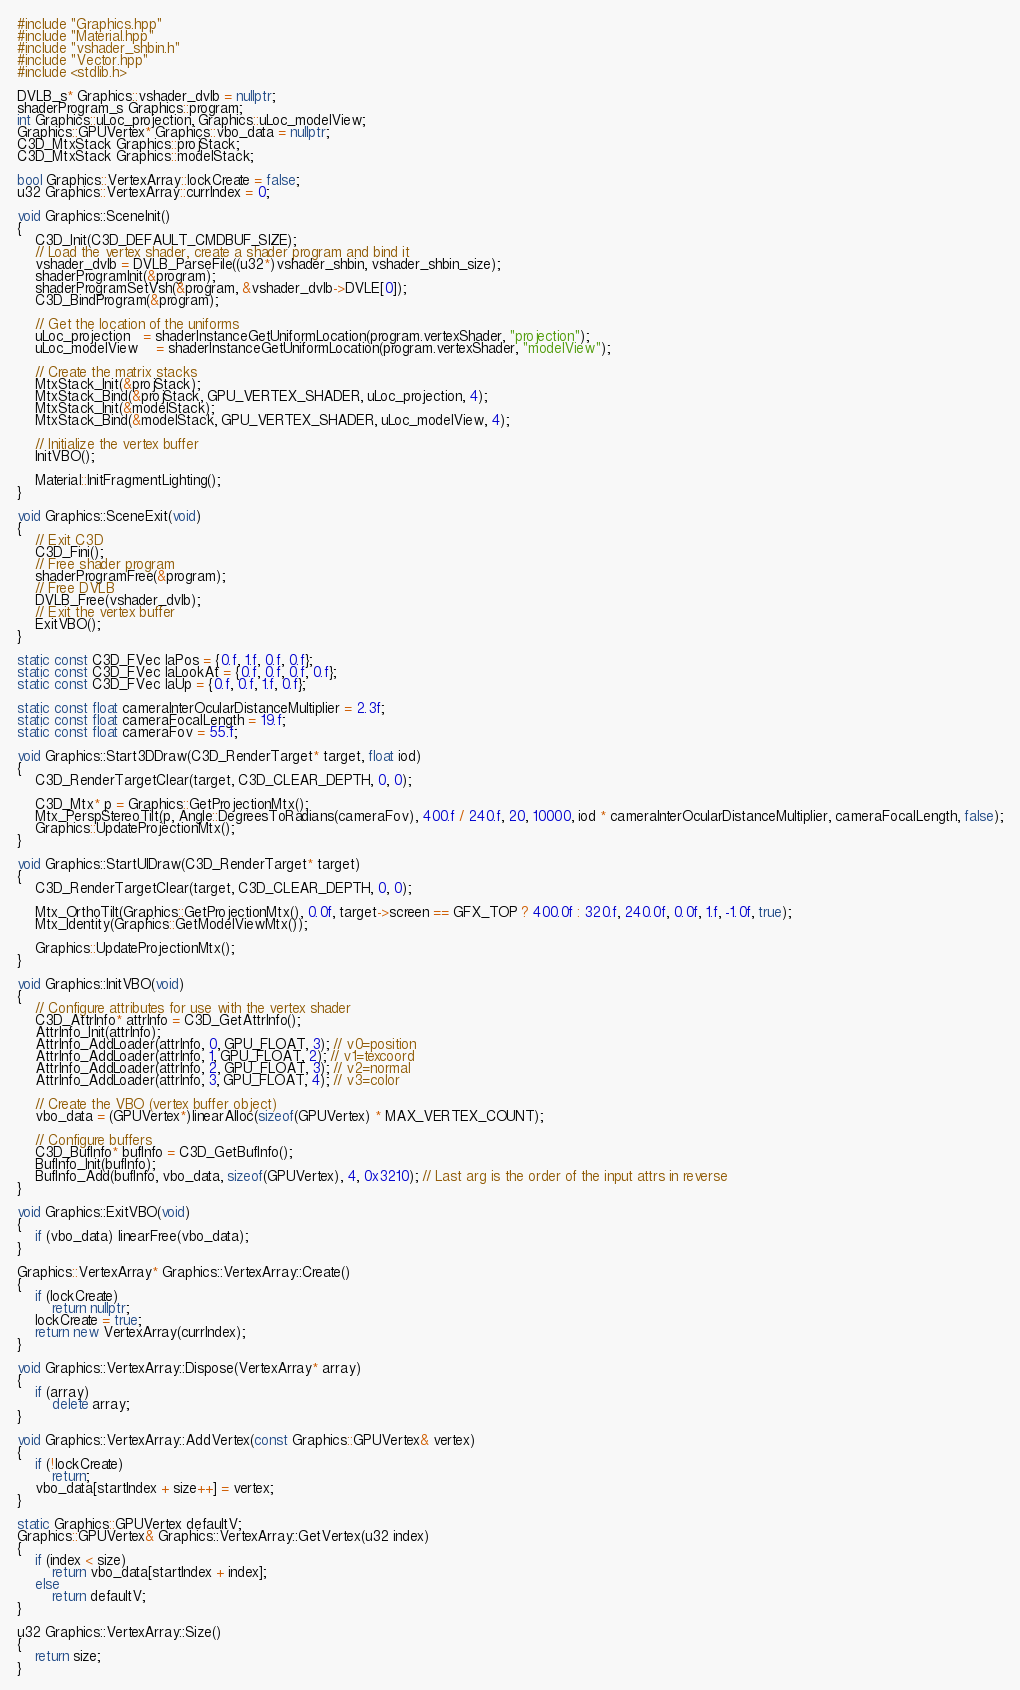<code> <loc_0><loc_0><loc_500><loc_500><_C++_>#include "Graphics.hpp"
#include "Material.hpp"
#include "vshader_shbin.h"
#include "Vector.hpp"
#include <stdlib.h>

DVLB_s* Graphics::vshader_dvlb = nullptr;
shaderProgram_s Graphics::program;
int Graphics::uLoc_projection, Graphics::uLoc_modelView;
Graphics::GPUVertex* Graphics::vbo_data = nullptr;
C3D_MtxStack Graphics::projStack;
C3D_MtxStack Graphics::modelStack;

bool Graphics::VertexArray::lockCreate = false;
u32 Graphics::VertexArray::currIndex = 0;

void Graphics::SceneInit()
{
	C3D_Init(C3D_DEFAULT_CMDBUF_SIZE);
    // Load the vertex shader, create a shader program and bind it
	vshader_dvlb = DVLB_ParseFile((u32*)vshader_shbin, vshader_shbin_size);
	shaderProgramInit(&program);
	shaderProgramSetVsh(&program, &vshader_dvlb->DVLE[0]);
	C3D_BindProgram(&program);

	// Get the location of the uniforms
	uLoc_projection   = shaderInstanceGetUniformLocation(program.vertexShader, "projection");
	uLoc_modelView    = shaderInstanceGetUniformLocation(program.vertexShader, "modelView");

	// Create the matrix stacks
	MtxStack_Init(&projStack);
	MtxStack_Bind(&projStack, GPU_VERTEX_SHADER, uLoc_projection, 4);
	MtxStack_Init(&modelStack);
	MtxStack_Bind(&modelStack, GPU_VERTEX_SHADER, uLoc_modelView, 4);

    // Initialize the vertex buffer
    InitVBO();

	Material::InitFragmentLighting();
}

void Graphics::SceneExit(void)
{
	// Exit C3D
	C3D_Fini();
	// Free shader program
	shaderProgramFree(&program);
	// Free DVLB
	DVLB_Free(vshader_dvlb);
	// Exit the vertex buffer
	ExitVBO();
}

static const C3D_FVec laPos = {0.f, 1.f, 0.f, 0.f};
static const C3D_FVec laLookAt = {0.f, 0.f, 0.f, 0.f};
static const C3D_FVec laUp = {0.f, 0.f, 1.f, 0.f};

static const float cameraInterOcularDistanceMultiplier = 2.3f;
static const float cameraFocalLength = 19.f;
static const float cameraFov = 55.f;

void Graphics::Start3DDraw(C3D_RenderTarget* target, float iod)
{
	C3D_RenderTargetClear(target, C3D_CLEAR_DEPTH, 0, 0);

    C3D_Mtx* p = Graphics::GetProjectionMtx();
    Mtx_PerspStereoTilt(p, Angle::DegreesToRadians(cameraFov), 400.f / 240.f, 20, 10000, iod * cameraInterOcularDistanceMultiplier, cameraFocalLength, false);
    Graphics::UpdateProjectionMtx();
}

void Graphics::StartUIDraw(C3D_RenderTarget* target)
{
    C3D_RenderTargetClear(target, C3D_CLEAR_DEPTH, 0, 0);

	Mtx_OrthoTilt(Graphics::GetProjectionMtx(), 0.0f, target->screen == GFX_TOP ? 400.0f : 320.f, 240.0f, 0.0f, 1.f, -1.0f, true);
	Mtx_Identity(Graphics::GetModelViewMtx());

    Graphics::UpdateProjectionMtx();
}

void Graphics::InitVBO(void)
{
    // Configure attributes for use with the vertex shader
	C3D_AttrInfo* attrInfo = C3D_GetAttrInfo();
	AttrInfo_Init(attrInfo);
	AttrInfo_AddLoader(attrInfo, 0, GPU_FLOAT, 3); // v0=position
	AttrInfo_AddLoader(attrInfo, 1, GPU_FLOAT, 2); // v1=texcoord
	AttrInfo_AddLoader(attrInfo, 2, GPU_FLOAT, 3); // v2=normal
    AttrInfo_AddLoader(attrInfo, 3, GPU_FLOAT, 4); // v3=color

	// Create the VBO (vertex buffer object)
	vbo_data = (GPUVertex*)linearAlloc(sizeof(GPUVertex) * MAX_VERTEX_COUNT);

	// Configure buffers
	C3D_BufInfo* bufInfo = C3D_GetBufInfo();
	BufInfo_Init(bufInfo);
	BufInfo_Add(bufInfo, vbo_data, sizeof(GPUVertex), 4, 0x3210); // Last arg is the order of the input attrs in reverse
}

void Graphics::ExitVBO(void)
{
	if (vbo_data) linearFree(vbo_data);
}

Graphics::VertexArray* Graphics::VertexArray::Create()
{
	if (lockCreate)
		return nullptr;
	lockCreate = true;
	return new VertexArray(currIndex);
}

void Graphics::VertexArray::Dispose(VertexArray* array)
{
	if (array)
		delete array;
}

void Graphics::VertexArray::AddVertex(const Graphics::GPUVertex& vertex)
{
	if (!lockCreate)
		return;
	vbo_data[startIndex + size++] = vertex;
}

static Graphics::GPUVertex defaultV;
Graphics::GPUVertex& Graphics::VertexArray::GetVertex(u32 index)
{
	if (index < size)
		return vbo_data[startIndex + index];
	else
		return defaultV;
}

u32 Graphics::VertexArray::Size()
{
	return size;
}
</code> 